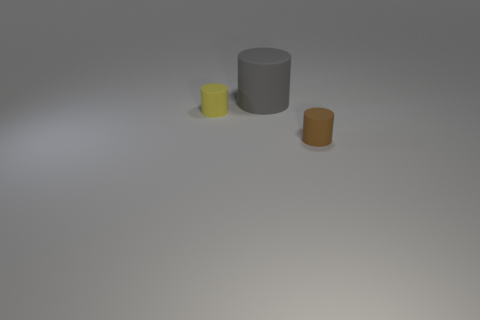What materials do the objects in the image seem to be made of? The objects in the image appear to have a plastic-like material, judging by their matte and smooth surfaces and the way they reflect light. Could you guess their possible uses? The cylindrical shapes suggest they could be containers or holders of some sort, perhaps for office supplies like pens, or small personal items. 